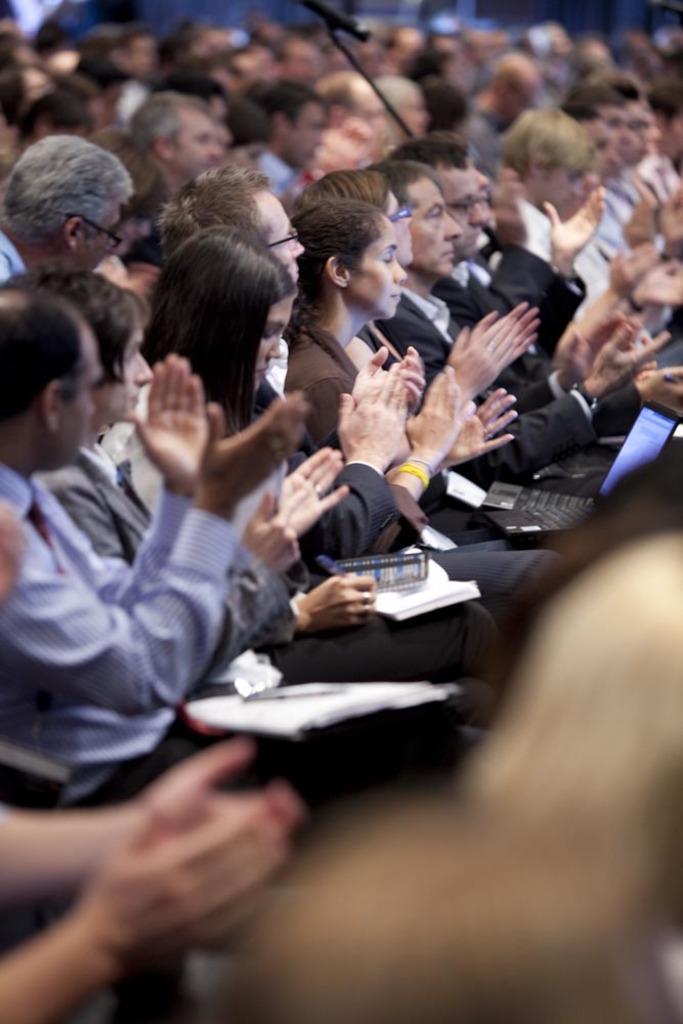Could you give a brief overview of what you see in this image? In this image in the center there are a group of people who are sitting and they are clapping, and some of them are holding some laptops and some of them are writing. 